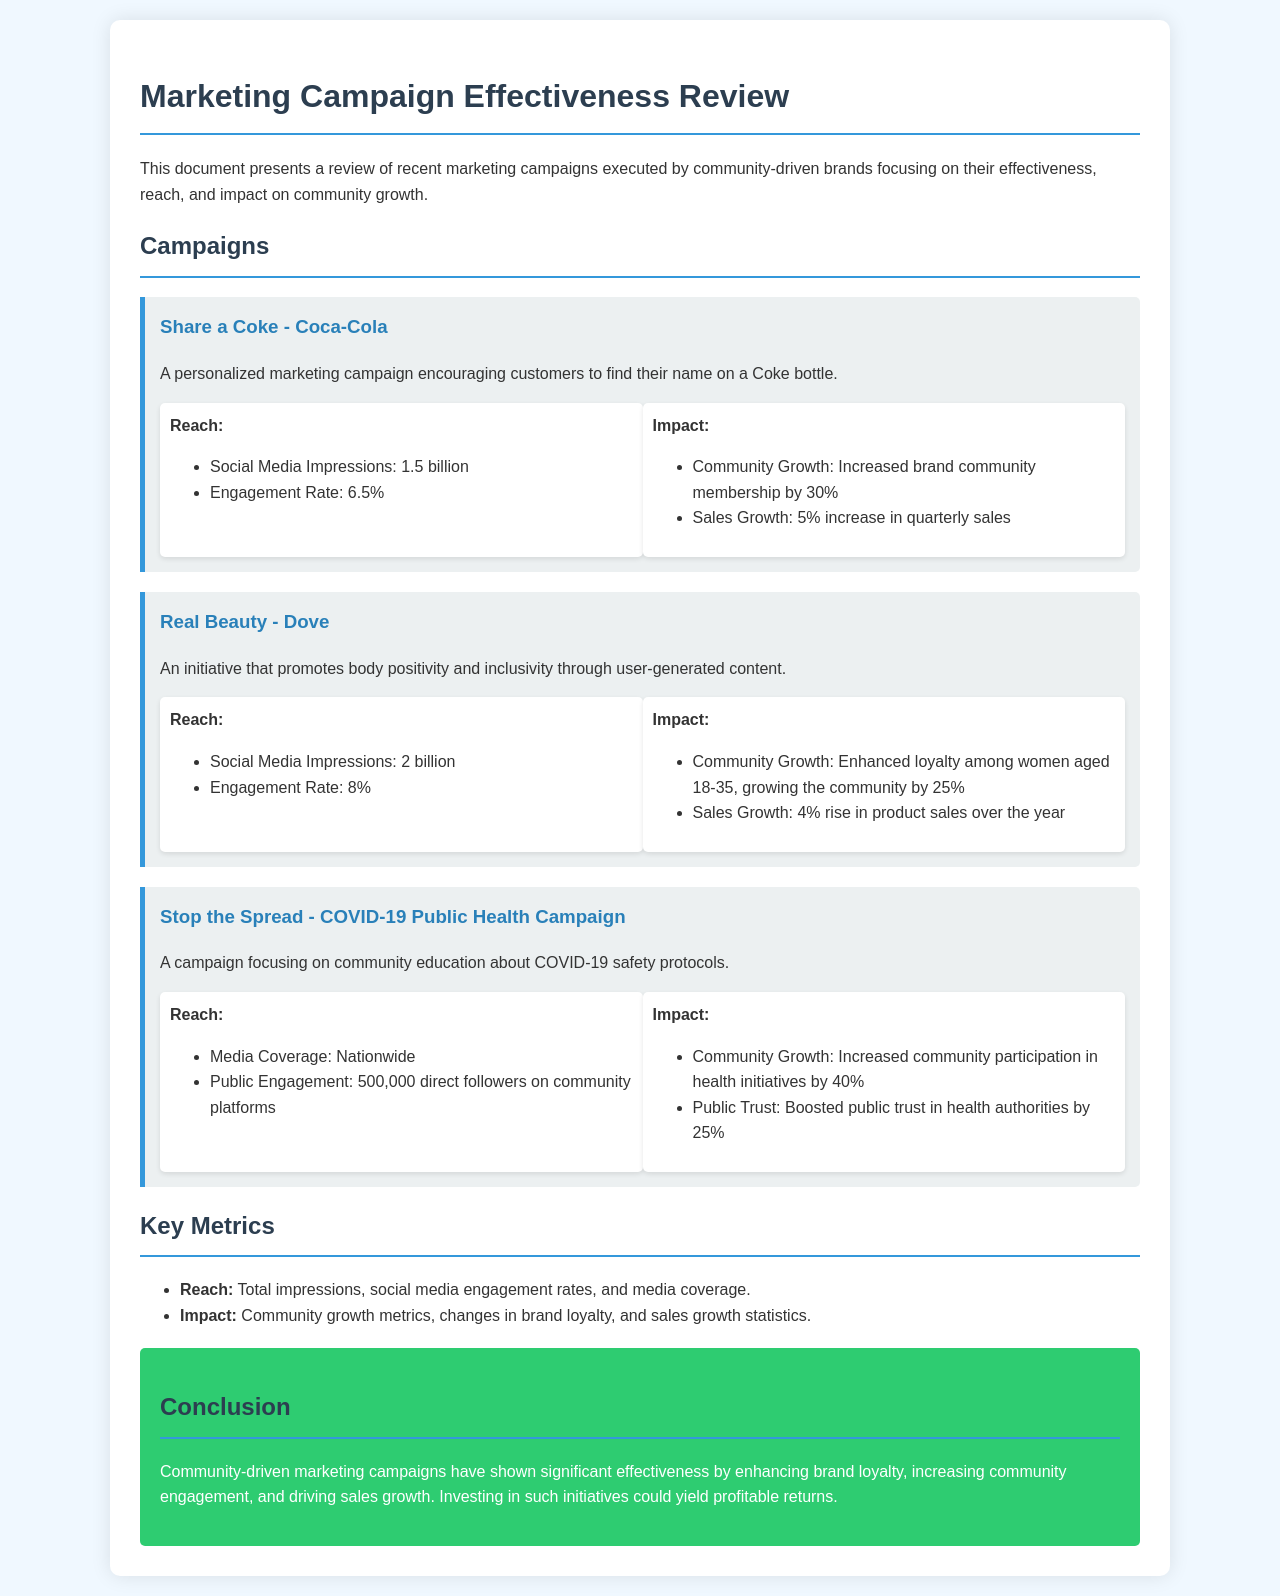What was the engagement rate of the Share a Coke campaign? The engagement rate for the Share a Coke campaign is given in the metrics section of the document.
Answer: 6.5% What was the community growth percentage for the Real Beauty campaign? The community growth percentage is detailed in the impact section under the Real Beauty campaign description.
Answer: 25% How many social media impressions did the Stop the Spread campaign achieve? The number of social media impressions is specified in the reach section of the Stop the Spread campaign.
Answer: Nationwide What was the increase in quarterly sales attributed to the Share a Coke campaign? The increase in quarterly sales is mentioned in the impact section of the Share a Coke campaign.
Answer: 5% Which campaign had the highest social media impressions? The document compares the social media impressions of the campaigns to determine which had the highest number.
Answer: Real Beauty What aspect of community engagement did the Stop the Spread campaign improve? The document specifies the particular area of community engagement that was improved by the Stop the Spread campaign.
Answer: Participation in health initiatives Which brand's initiative focused on body positivity? The document clearly states which brand's initiative was centered around body positivity.
Answer: Dove What conclusion can be drawn about community-driven marketing campaigns? The conclusion section summarizes the overall effectiveness of community-driven marketing campaigns.
Answer: Significant effectiveness 